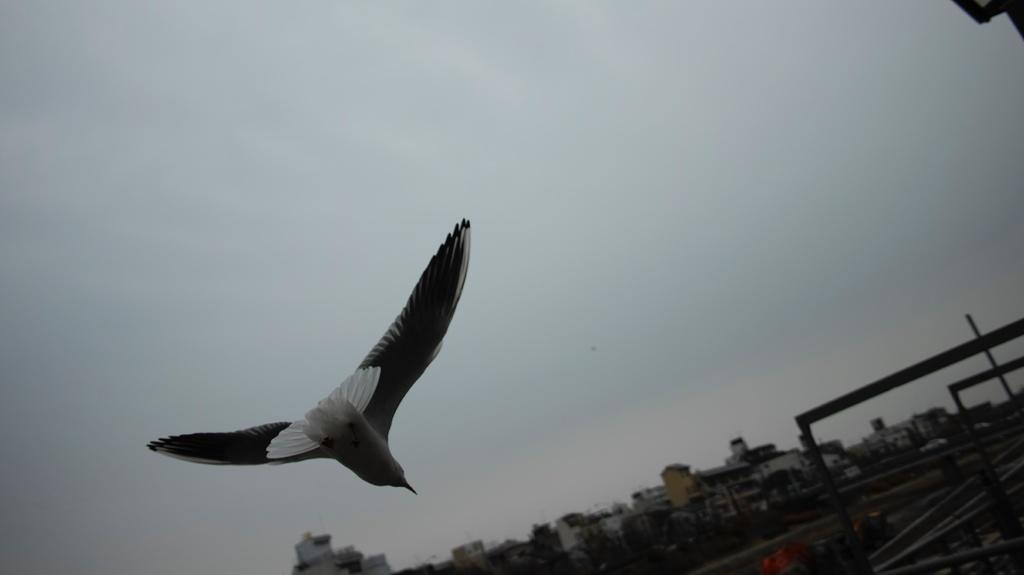What is flying in the sky in the image? There is a bird flying in the sky in the image. What structures can be seen at the bottom of the image? There are buildings at the bottom of the image. What type of vegetation is present on the ground in the image? There are trees on the ground in the image. What is visible at the top of the image? The sky is visible at the top of the image. Can you see any pears growing on the trees in the image? There are no pears visible in the image; only trees are present. Does the existence of the bird in the image prove the existence of life on other planets? The presence of a bird in the image does not provide any information about the existence of life on other planets. 